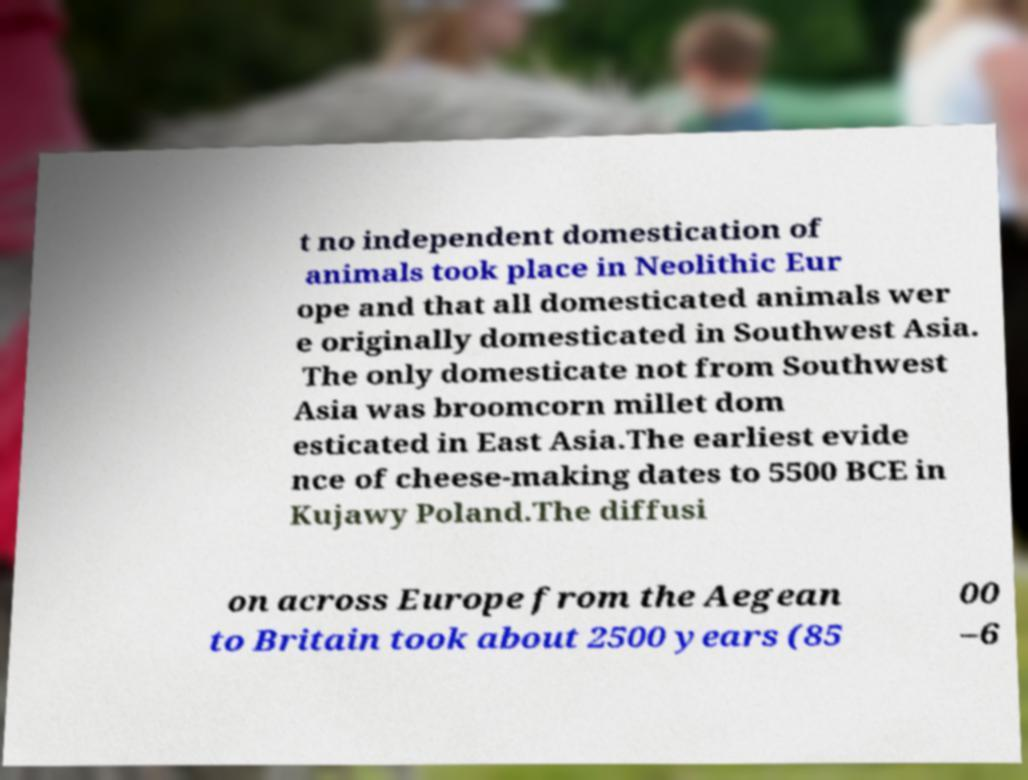For documentation purposes, I need the text within this image transcribed. Could you provide that? t no independent domestication of animals took place in Neolithic Eur ope and that all domesticated animals wer e originally domesticated in Southwest Asia. The only domesticate not from Southwest Asia was broomcorn millet dom esticated in East Asia.The earliest evide nce of cheese-making dates to 5500 BCE in Kujawy Poland.The diffusi on across Europe from the Aegean to Britain took about 2500 years (85 00 –6 